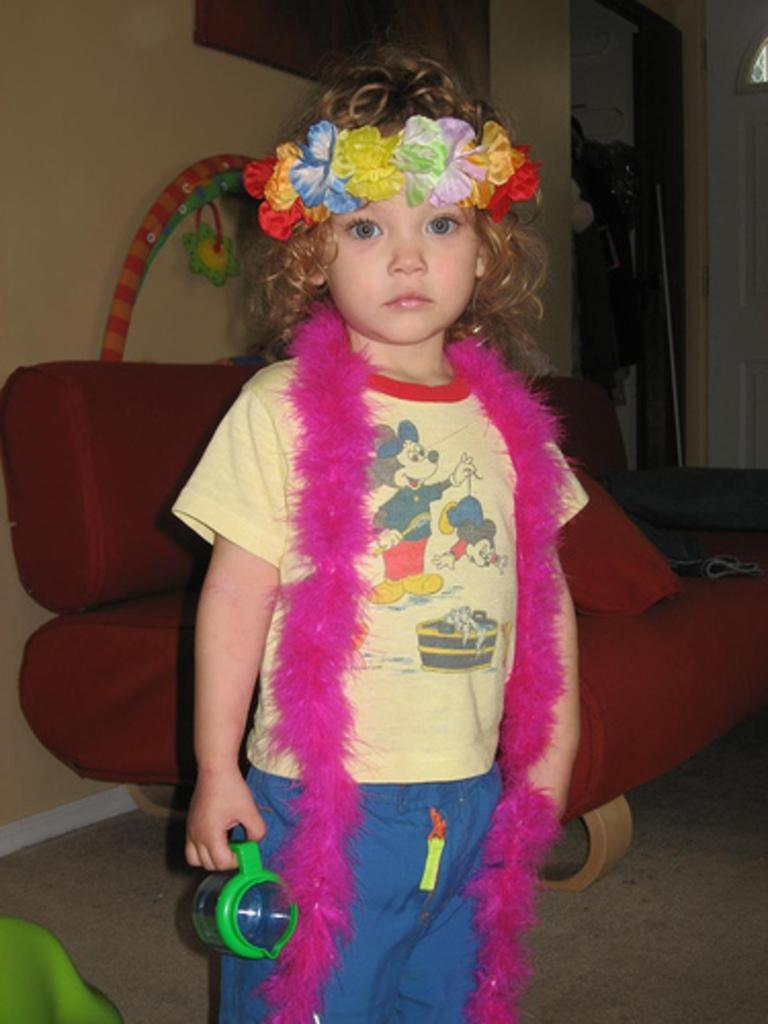What is the main subject of the image? There is a beautiful girl in the image. Where is the girl positioned in the image? The girl is standing in the middle of the image. What is the girl wearing around her neck? The girl is wearing a garland. What color is the girl's t-shirt? The girl is wearing a yellow t-shirt. What color are the girl's trousers? The girl is wearing blue trousers. What can be seen in the background of the image? There is a red sofa in the background of the image. How much money is the girl holding in the image? There is no indication of money in the image; the girl is not holding any. Are there any fairies visible in the image? There are no fairies present in the image; it features a beautiful girl standing in the middle of the image. 